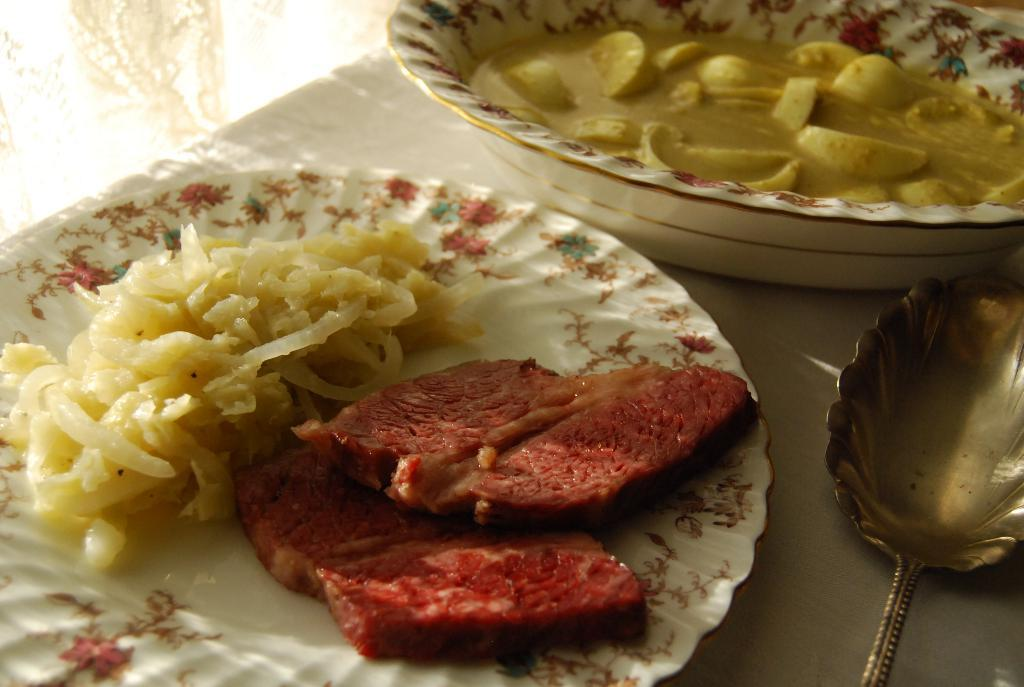What type of objects can be seen in the image? There are food items in the image. How are the food items presented? The food items are on white plates. How much money is being exchanged in the image? There is no money present in the image; it features food items on white plates. What stage of development is depicted in the image? There is no development being depicted in the image; it features food items on white plates. 